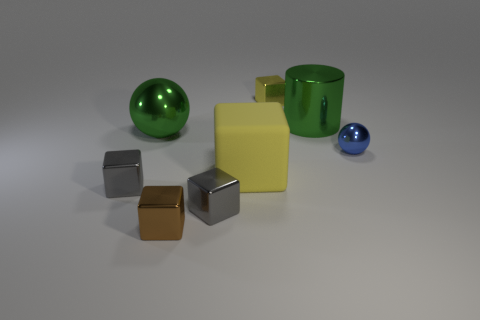Are there any other things that have the same color as the large matte block?
Give a very brief answer. Yes. Are there fewer small brown metallic objects to the right of the brown block than big balls?
Give a very brief answer. Yes. What number of small yellow things are there?
Keep it short and to the point. 1. There is a tiny yellow shiny object; does it have the same shape as the green metallic thing on the left side of the large yellow thing?
Provide a short and direct response. No. Is the number of green metallic cylinders on the right side of the small blue shiny sphere less than the number of metal spheres that are left of the big yellow matte cube?
Your response must be concise. Yes. Are there any other things that are the same shape as the tiny blue object?
Your answer should be compact. Yes. Do the blue metal thing and the yellow metal object have the same shape?
Provide a short and direct response. No. Is there anything else that is made of the same material as the blue ball?
Your answer should be compact. Yes. What size is the green sphere?
Your answer should be very brief. Large. The metallic thing that is both in front of the yellow matte block and left of the brown object is what color?
Your response must be concise. Gray. 